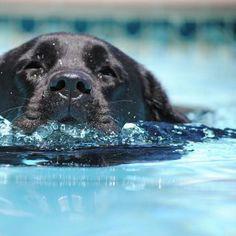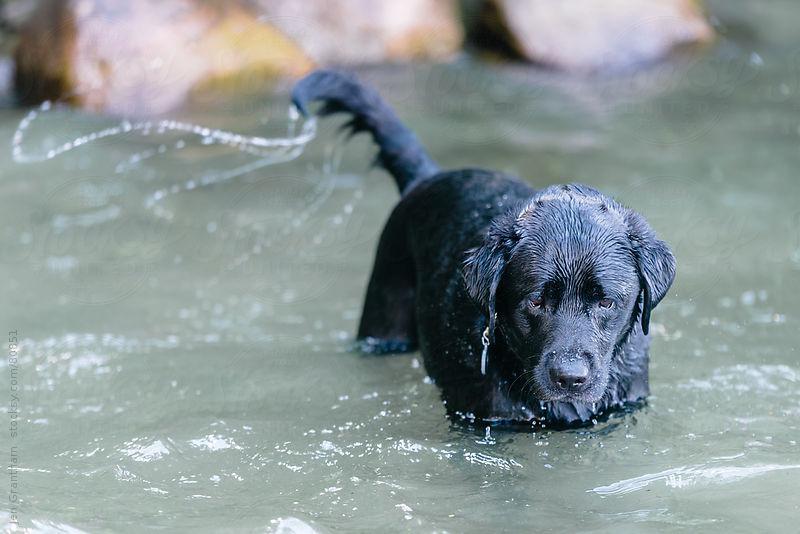The first image is the image on the left, the second image is the image on the right. Given the left and right images, does the statement "At least one dog has it's tail out of the water." hold true? Answer yes or no. Yes. The first image is the image on the left, the second image is the image on the right. Considering the images on both sides, is "In one image the dog is facing forward, and in the other it is facing to the side." valid? Answer yes or no. No. 